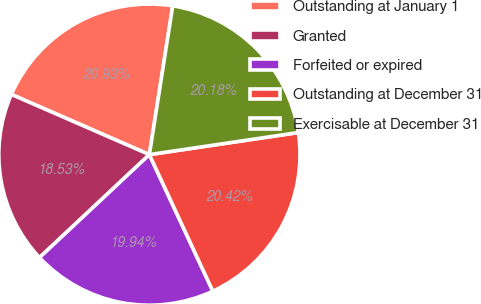Convert chart to OTSL. <chart><loc_0><loc_0><loc_500><loc_500><pie_chart><fcel>Outstanding at January 1<fcel>Granted<fcel>Forfeited or expired<fcel>Outstanding at December 31<fcel>Exercisable at December 31<nl><fcel>20.93%<fcel>18.53%<fcel>19.94%<fcel>20.42%<fcel>20.18%<nl></chart> 